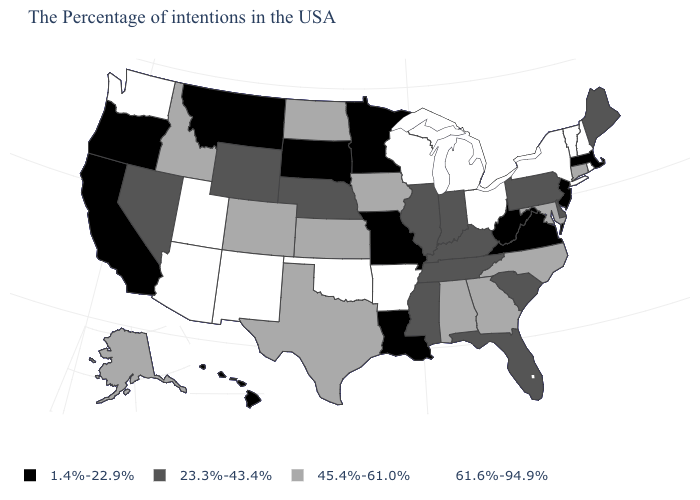Which states hav the highest value in the West?
Quick response, please. New Mexico, Utah, Arizona, Washington. What is the value of West Virginia?
Write a very short answer. 1.4%-22.9%. What is the value of North Carolina?
Write a very short answer. 45.4%-61.0%. What is the value of Mississippi?
Concise answer only. 23.3%-43.4%. Name the states that have a value in the range 45.4%-61.0%?
Short answer required. Connecticut, Maryland, North Carolina, Georgia, Alabama, Iowa, Kansas, Texas, North Dakota, Colorado, Idaho, Alaska. What is the highest value in the MidWest ?
Answer briefly. 61.6%-94.9%. Does the map have missing data?
Concise answer only. No. Which states hav the highest value in the West?
Give a very brief answer. New Mexico, Utah, Arizona, Washington. What is the lowest value in the Northeast?
Write a very short answer. 1.4%-22.9%. What is the highest value in the South ?
Give a very brief answer. 61.6%-94.9%. Name the states that have a value in the range 1.4%-22.9%?
Short answer required. Massachusetts, New Jersey, Virginia, West Virginia, Louisiana, Missouri, Minnesota, South Dakota, Montana, California, Oregon, Hawaii. Does Oregon have a lower value than California?
Short answer required. No. Name the states that have a value in the range 61.6%-94.9%?
Be succinct. Rhode Island, New Hampshire, Vermont, New York, Ohio, Michigan, Wisconsin, Arkansas, Oklahoma, New Mexico, Utah, Arizona, Washington. What is the value of New Jersey?
Give a very brief answer. 1.4%-22.9%. Name the states that have a value in the range 23.3%-43.4%?
Give a very brief answer. Maine, Delaware, Pennsylvania, South Carolina, Florida, Kentucky, Indiana, Tennessee, Illinois, Mississippi, Nebraska, Wyoming, Nevada. 